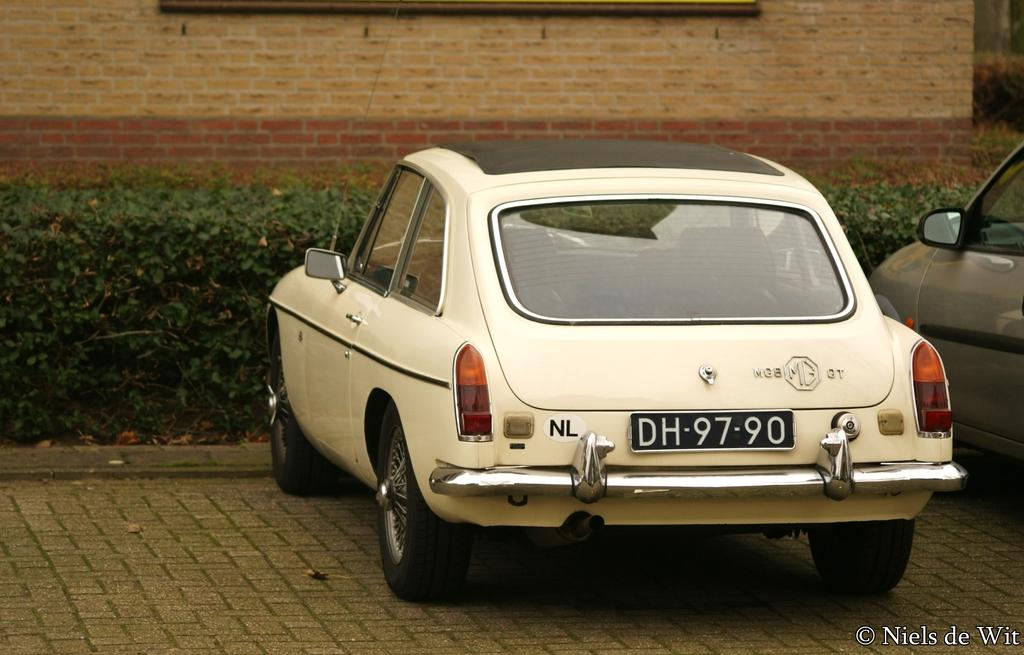What color is the car that is parked in the image? The car that is parked in the image is white. What is the position of the white car in the image? The white car is parked in the image. Is there another car parked near the white car? Yes, there is another car parked beside the white car. What can be seen in the background of the image? There are green plants and a brick wall in the background of the image. What type of book is the flag reading in the image? There is no flag or book present in the image. What mathematical operation is being performed on the addition sign in the image? There is no addition sign or mathematical operation present in the image. 